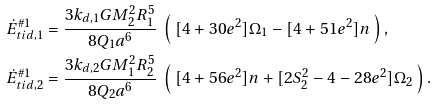<formula> <loc_0><loc_0><loc_500><loc_500>\dot { E } _ { t i d , 1 } ^ { \# 1 } & = \frac { 3 k _ { d , 1 } G M _ { 2 } ^ { 2 } R _ { 1 } ^ { 5 } } { 8 Q _ { 1 } a ^ { 6 } } \ \left ( \ [ 4 + 3 0 e ^ { 2 } ] \Omega _ { 1 } - [ 4 + 5 1 e ^ { 2 } ] n \ \right ) , \\ \dot { E } _ { t i d , 2 } ^ { \# 1 } & = \frac { 3 k _ { d , 2 } G M _ { 1 } ^ { 2 } R _ { 2 } ^ { 5 } } { 8 Q _ { 2 } a ^ { 6 } } \ \left ( \ [ 4 + 5 6 e ^ { 2 } ] n + [ 2 S _ { 2 } ^ { 2 } - 4 - 2 8 e ^ { 2 } ] \Omega _ { 2 } \ \right ) .</formula> 